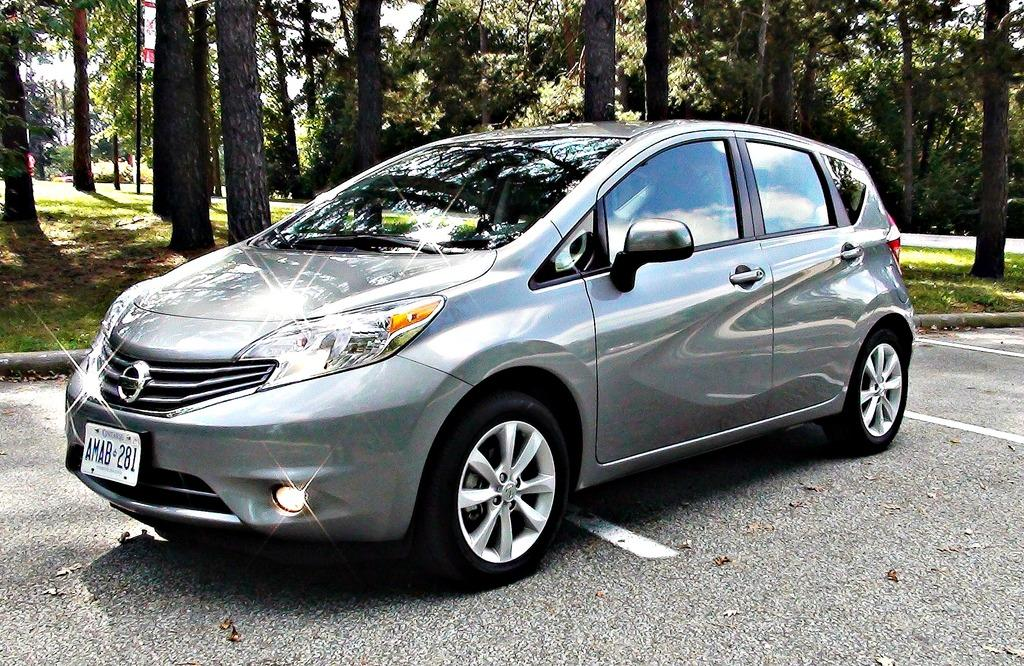What is the main subject of the image? There is a car on the road in the image. What type of vegetation can be seen in the image? Grass is visible in the image. What else can be seen in the image besides the car and grass? Tree trunks are present in the image. What is visible in the background of the image? The sky is visible in the image. Can you tell me how many receipts are scattered on the ground in the image? There are no receipts present in the image. How many boys are playing near the car in the image? There are no boys present in the image. 